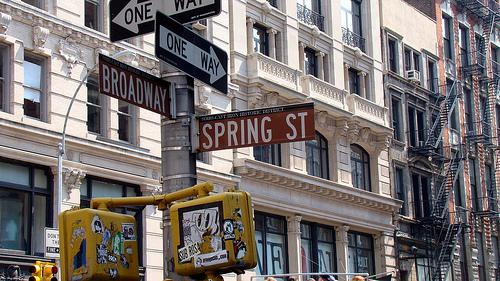Question: what is the focus?
Choices:
A. Cars.
B. People.
C. Traffic lights.
D. Intersection signs.
Answer with the letter. Answer: D Question: where was this shot?
Choices:
A. Crosswalk.
B. Sidewalk.
C. Street.
D. Building.
Answer with the letter. Answer: A Question: what do the matching signs say?
Choices:
A. Stop.
B. No turn on red.
C. Pedestrian crossing.
D. One way.
Answer with the letter. Answer: D Question: what does the red sign say?
Choices:
A. Stop.
B. No left turn.
C. Main st.
D. Spring st.
Answer with the letter. Answer: D Question: where is this at?
Choices:
A. Broadway and Main St.
B. Spring and Main St.
C. Broadway and spring street.
D. Spring and Summer St.
Answer with the letter. Answer: C 